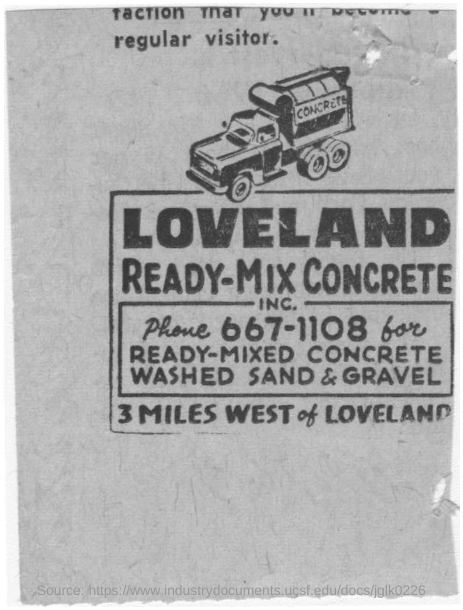What is Written on the truck?
Give a very brief answer. Concrete. What is Written in bold ?
Your response must be concise. Loveland. What phone number is mentioned for ready-mix concrete, washed sand & gravel?
Give a very brief answer. 667-1108. 